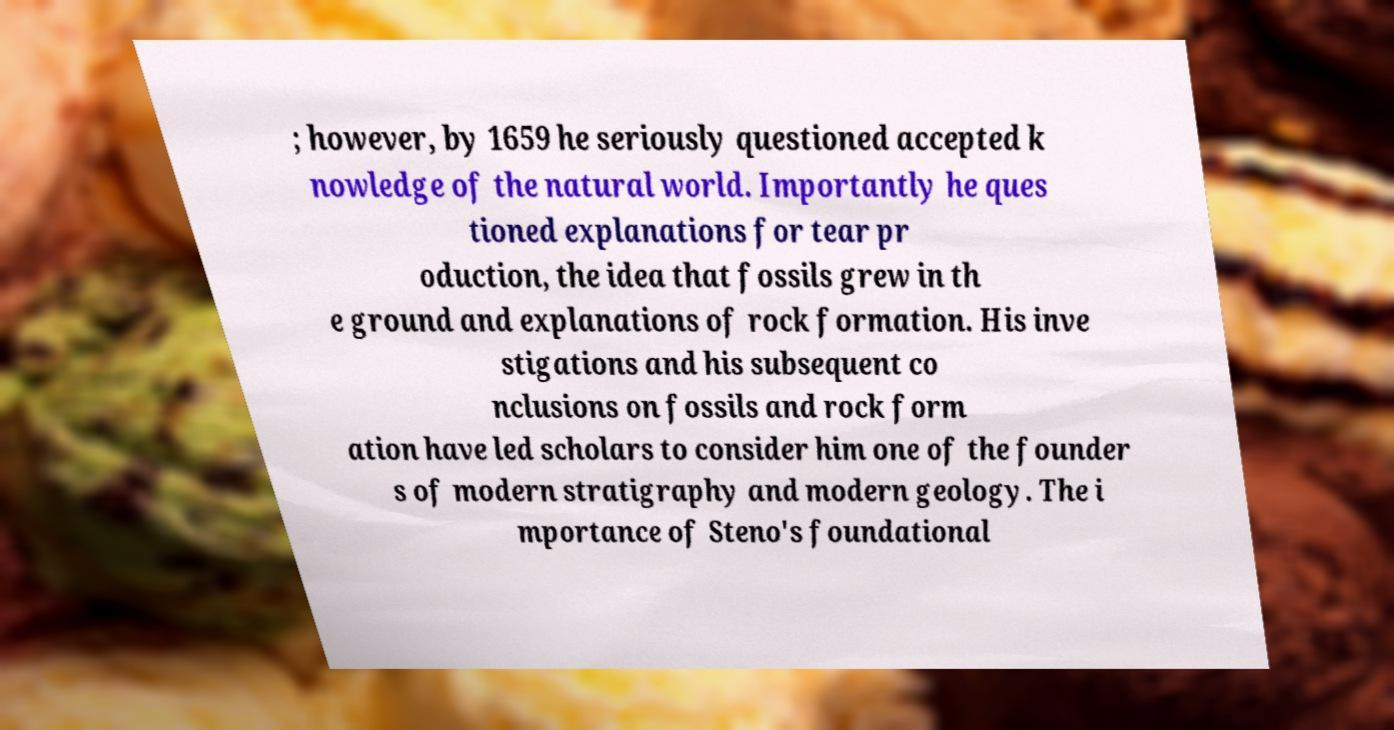Can you read and provide the text displayed in the image?This photo seems to have some interesting text. Can you extract and type it out for me? ; however, by 1659 he seriously questioned accepted k nowledge of the natural world. Importantly he ques tioned explanations for tear pr oduction, the idea that fossils grew in th e ground and explanations of rock formation. His inve stigations and his subsequent co nclusions on fossils and rock form ation have led scholars to consider him one of the founder s of modern stratigraphy and modern geology. The i mportance of Steno's foundational 